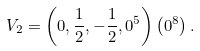Convert formula to latex. <formula><loc_0><loc_0><loc_500><loc_500>V _ { 2 } = \left ( 0 , \frac { 1 } { 2 } , - \frac { 1 } { 2 } , 0 ^ { 5 } \right ) \left ( 0 ^ { 8 } \right ) .</formula> 